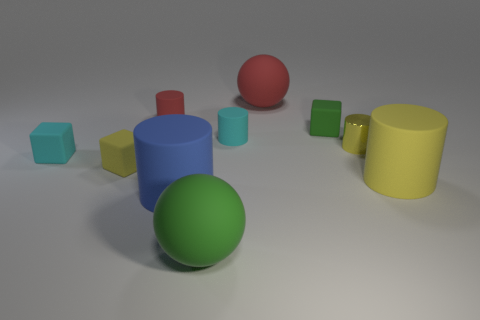What material is the tiny block in front of the tiny cyan matte block?
Your answer should be compact. Rubber. What number of tiny objects are either yellow matte things or cubes?
Provide a succinct answer. 3. There is a block that is the same color as the metal cylinder; what is it made of?
Your answer should be compact. Rubber. Are there any large gray spheres made of the same material as the small green thing?
Your answer should be compact. No. Do the sphere to the left of the red matte ball and the yellow metallic cylinder have the same size?
Offer a very short reply. No. Is there a cyan cube right of the tiny thing left of the yellow rubber cube behind the large yellow object?
Your answer should be compact. No. What number of matte objects are either big cylinders or tiny cylinders?
Give a very brief answer. 4. How many other objects are the same shape as the metal thing?
Make the answer very short. 4. Is the number of big cyan shiny balls greater than the number of small cubes?
Offer a terse response. No. What is the size of the yellow thing on the left side of the large object that is behind the tiny cyan thing that is behind the tiny shiny cylinder?
Your answer should be compact. Small. 